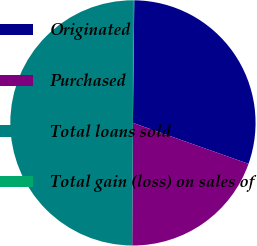<chart> <loc_0><loc_0><loc_500><loc_500><pie_chart><fcel>Originated<fcel>Purchased<fcel>Total loans sold<fcel>Total gain (loss) on sales of<nl><fcel>30.24%<fcel>19.67%<fcel>49.91%<fcel>0.17%<nl></chart> 